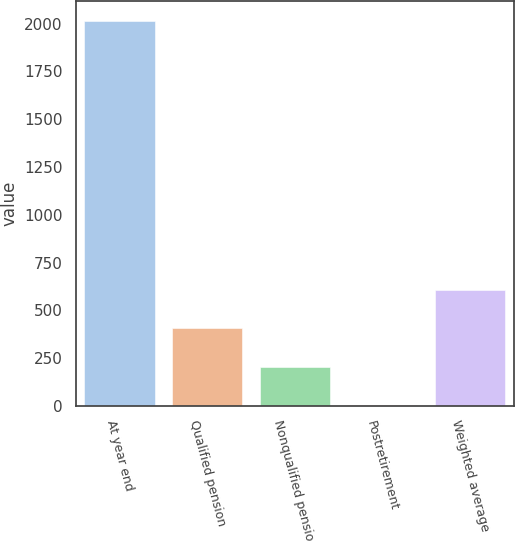Convert chart to OTSL. <chart><loc_0><loc_0><loc_500><loc_500><bar_chart><fcel>At year end<fcel>Qualified pension<fcel>Nonqualified pension<fcel>Postretirement<fcel>Weighted average<nl><fcel>2016<fcel>406.32<fcel>205.11<fcel>3.9<fcel>607.53<nl></chart> 